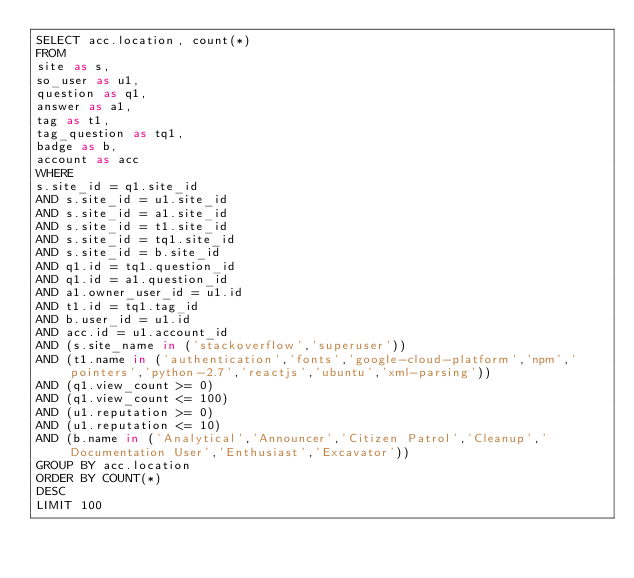<code> <loc_0><loc_0><loc_500><loc_500><_SQL_>SELECT acc.location, count(*)
FROM
site as s,
so_user as u1,
question as q1,
answer as a1,
tag as t1,
tag_question as tq1,
badge as b,
account as acc
WHERE
s.site_id = q1.site_id
AND s.site_id = u1.site_id
AND s.site_id = a1.site_id
AND s.site_id = t1.site_id
AND s.site_id = tq1.site_id
AND s.site_id = b.site_id
AND q1.id = tq1.question_id
AND q1.id = a1.question_id
AND a1.owner_user_id = u1.id
AND t1.id = tq1.tag_id
AND b.user_id = u1.id
AND acc.id = u1.account_id
AND (s.site_name in ('stackoverflow','superuser'))
AND (t1.name in ('authentication','fonts','google-cloud-platform','npm','pointers','python-2.7','reactjs','ubuntu','xml-parsing'))
AND (q1.view_count >= 0)
AND (q1.view_count <= 100)
AND (u1.reputation >= 0)
AND (u1.reputation <= 10)
AND (b.name in ('Analytical','Announcer','Citizen Patrol','Cleanup','Documentation User','Enthusiast','Excavator'))
GROUP BY acc.location
ORDER BY COUNT(*)
DESC
LIMIT 100
</code> 